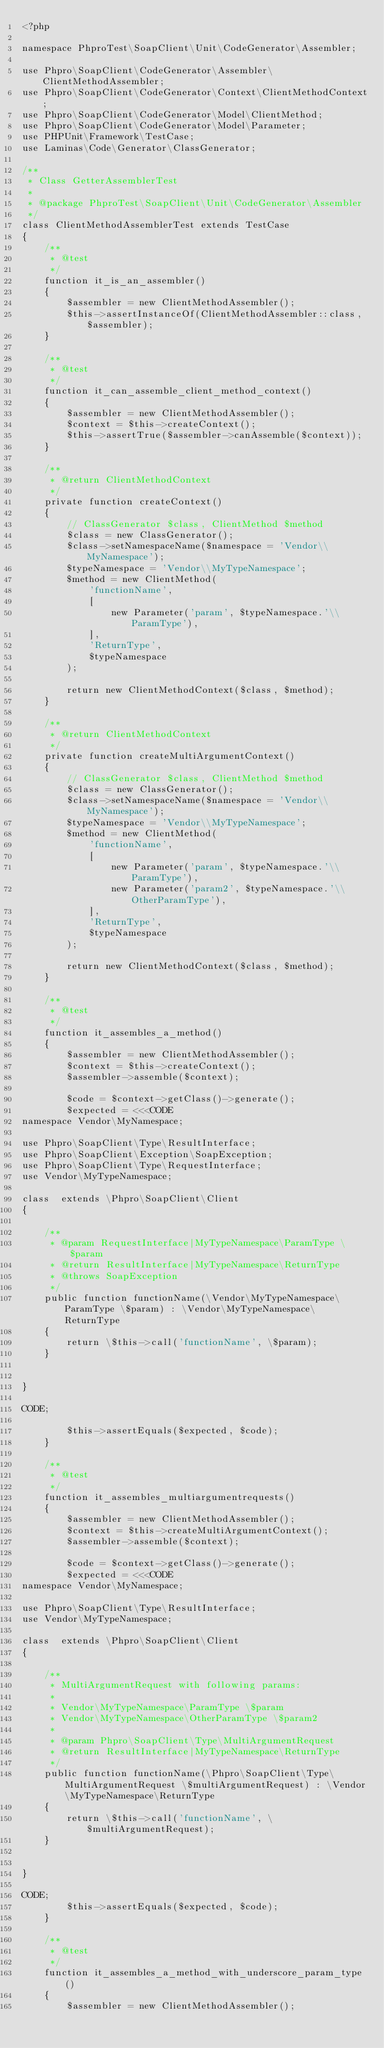Convert code to text. <code><loc_0><loc_0><loc_500><loc_500><_PHP_><?php

namespace PhproTest\SoapClient\Unit\CodeGenerator\Assembler;

use Phpro\SoapClient\CodeGenerator\Assembler\ClientMethodAssembler;
use Phpro\SoapClient\CodeGenerator\Context\ClientMethodContext;
use Phpro\SoapClient\CodeGenerator\Model\ClientMethod;
use Phpro\SoapClient\CodeGenerator\Model\Parameter;
use PHPUnit\Framework\TestCase;
use Laminas\Code\Generator\ClassGenerator;

/**
 * Class GetterAssemblerTest
 *
 * @package PhproTest\SoapClient\Unit\CodeGenerator\Assembler
 */
class ClientMethodAssemblerTest extends TestCase
{
    /**
     * @test
     */
    function it_is_an_assembler()
    {
        $assembler = new ClientMethodAssembler();
        $this->assertInstanceOf(ClientMethodAssembler::class, $assembler);
    }

    /**
     * @test
     */
    function it_can_assemble_client_method_context()
    {
        $assembler = new ClientMethodAssembler();
        $context = $this->createContext();
        $this->assertTrue($assembler->canAssemble($context));
    }

    /**
     * @return ClientMethodContext
     */
    private function createContext()
    {
        // ClassGenerator $class, ClientMethod $method
        $class = new ClassGenerator();
        $class->setNamespaceName($namespace = 'Vendor\\MyNamespace');
        $typeNamespace = 'Vendor\\MyTypeNamespace';
        $method = new ClientMethod(
            'functionName',
            [
                new Parameter('param', $typeNamespace.'\\ParamType'),
            ],
            'ReturnType',
            $typeNamespace
        );

        return new ClientMethodContext($class, $method);
    }

    /**
     * @return ClientMethodContext
     */
    private function createMultiArgumentContext()
    {
        // ClassGenerator $class, ClientMethod $method
        $class = new ClassGenerator();
        $class->setNamespaceName($namespace = 'Vendor\\MyNamespace');
        $typeNamespace = 'Vendor\\MyTypeNamespace';
        $method = new ClientMethod(
            'functionName',
            [
                new Parameter('param', $typeNamespace.'\\ParamType'),
                new Parameter('param2', $typeNamespace.'\\OtherParamType'),
            ],
            'ReturnType',
            $typeNamespace
        );

        return new ClientMethodContext($class, $method);
    }

    /**
     * @test
     */
    function it_assembles_a_method()
    {
        $assembler = new ClientMethodAssembler();
        $context = $this->createContext();
        $assembler->assemble($context);

        $code = $context->getClass()->generate();
        $expected = <<<CODE
namespace Vendor\MyNamespace;

use Phpro\SoapClient\Type\ResultInterface;
use Phpro\SoapClient\Exception\SoapException;
use Phpro\SoapClient\Type\RequestInterface;
use Vendor\MyTypeNamespace;

class  extends \Phpro\SoapClient\Client
{

    /**
     * @param RequestInterface|MyTypeNamespace\ParamType \$param
     * @return ResultInterface|MyTypeNamespace\ReturnType
     * @throws SoapException
     */
    public function functionName(\Vendor\MyTypeNamespace\ParamType \$param) : \Vendor\MyTypeNamespace\ReturnType
    {
        return \$this->call('functionName', \$param);
    }


}

CODE;

        $this->assertEquals($expected, $code);
    }

    /**
     * @test
     */
    function it_assembles_multiargumentrequests()
    {
        $assembler = new ClientMethodAssembler();
        $context = $this->createMultiArgumentContext();
        $assembler->assemble($context);

        $code = $context->getClass()->generate();
        $expected = <<<CODE
namespace Vendor\MyNamespace;

use Phpro\SoapClient\Type\ResultInterface;
use Vendor\MyTypeNamespace;

class  extends \Phpro\SoapClient\Client
{

    /**
     * MultiArgumentRequest with following params:
     *
     * Vendor\MyTypeNamespace\ParamType \$param
     * Vendor\MyTypeNamespace\OtherParamType \$param2
     *
     * @param Phpro\SoapClient\Type\MultiArgumentRequest
     * @return ResultInterface|MyTypeNamespace\ReturnType
     */
    public function functionName(\Phpro\SoapClient\Type\MultiArgumentRequest \$multiArgumentRequest) : \Vendor\MyTypeNamespace\ReturnType
    {
        return \$this->call('functionName', \$multiArgumentRequest);
    }


}

CODE;
        $this->assertEquals($expected, $code);
    }

    /**
     * @test
     */
    function it_assembles_a_method_with_underscore_param_type()
    {
        $assembler = new ClientMethodAssembler();</code> 